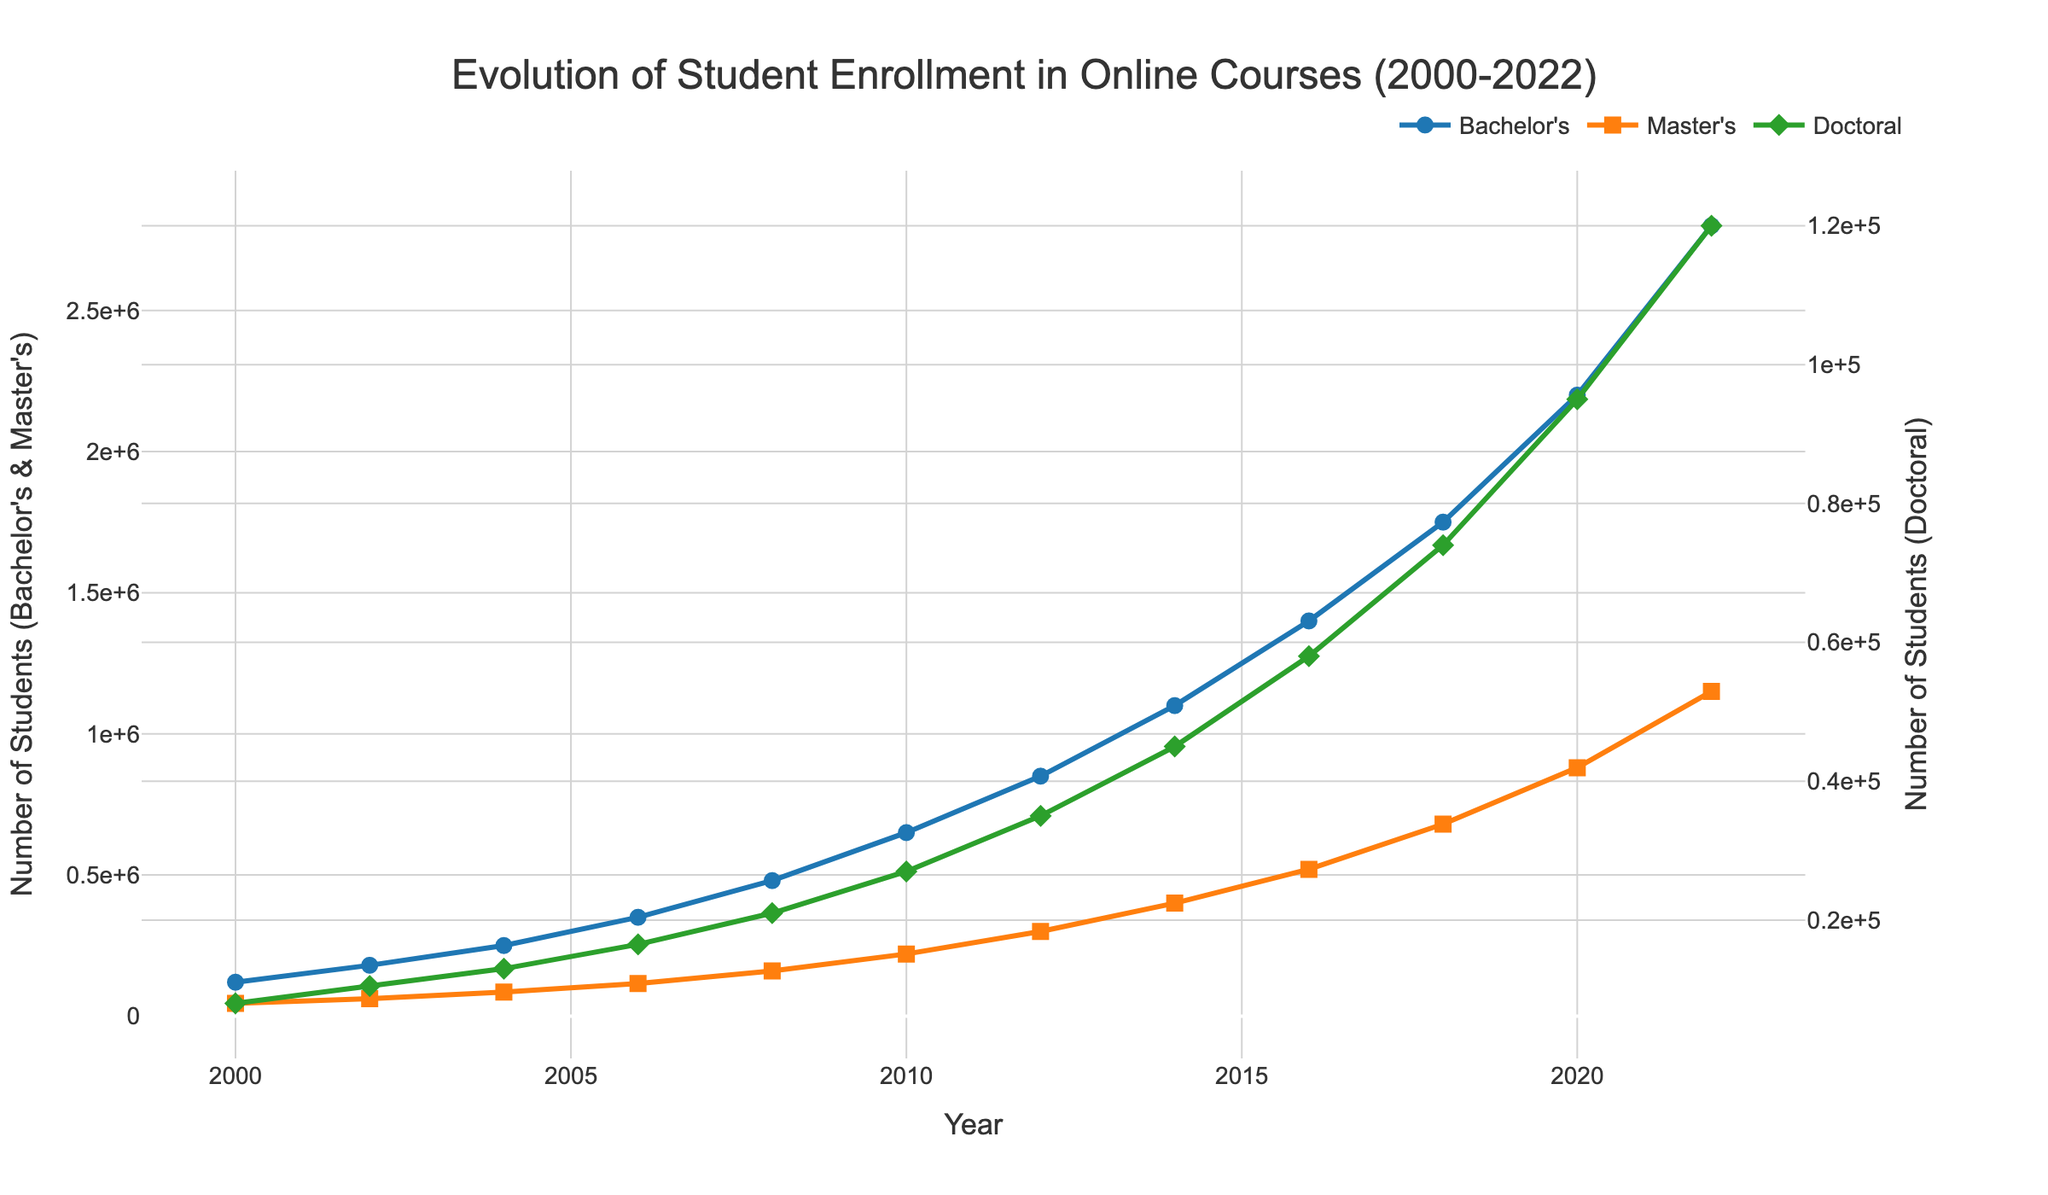What is the overall trend in Bachelor's enrollment from 2000 to 2022? The graph shows a line for Bachelor's enrollment that increases steadily from 2000 to 2022, indicating a consistent upward trend.
Answer: Consistent upward trend How much higher is the Bachelor's enrollment in 2022 compared to 2000? The Bachelor's enrollment in 2000 is 120,000 and in 2022 is 2,800,000. The difference is 2,800,000 - 120,000 = 2,680,000.
Answer: 2,680,000 Which degree level had the highest enrollment in 2014? By observing the 2014 data points, the Bachelor's line is the highest compared to Master's and Doctoral levels.
Answer: Bachelor's How did Master's enrollment change from 2016 to 2022? In 2016, the Master's enrollment was 520,000, and in 2022 it was 1,150,000. The difference is 1,150,000 - 520,000 = 630,000, which indicates an increase.
Answer: Increased by 630,000 Between 2010 and 2018, which degree level saw the greatest absolute increase in enrollment? Comparing the data from 2010 to 2018 for each degree level: Bachelor's increased from 650,000 to 1,750,000 (1,100,000 increase), Master's from 220,000 to 680,000 (460,000 increase), and Doctoral from 27,000 to 74,000 (47,000 increase). The greatest increase is in Bachelor's.
Answer: Bachelor's What is the relationship between Master's and Doctoral enrollments in 2008 based on their visual proportions? In 2008, the Master's enrollment (160,000) is greater than the Doctoral enrollment (21,000). Visually, the Master's line is higher than the Doctoral line on the primary y-axis.
Answer: Master's is greater than Doctoral What is the average annual increase in Bachelor's enrollment from 2000 to 2022? The total increase in Bachelor's enrollment from 2000 to 2022 is 2,800,000 - 120,000 = 2,680,000. The period is 22 years (2022-2000). The average annual increase is 2,680,000 / 22 ≈ 121,818.
Answer: ≈ 121,818 Which year shows the first major jump in Master's enrollment, and how much did it increase by compared to the previous data point? The major jump in Master's enrollment can be seen from 2006 (115,000) to 2008 (160,000), an increase of 160,000 - 115,000 = 45,000.
Answer: 2008, 45,000 From 2000 to 2008, which degree level showed the least growth and by how much? Comparing the 2000 to 2008 data points: Bachelor's grew from 120,000 to 480,000 (360,000 increase), Master's from 45,000 to 160,000 (115,000 increase), and Doctoral from 8,000 to 21,000 (13,000 increase). The least growth is in Doctoral with 13,000.
Answer: Doctoral, 13,000 